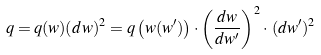<formula> <loc_0><loc_0><loc_500><loc_500>q = q ( w ) ( d w ) ^ { 2 } = q \left ( w ( w ^ { \prime } ) \right ) \cdot \left ( \frac { d w } { d w ^ { \prime } } \right ) ^ { 2 } \cdot \, ( d w ^ { \prime } ) ^ { 2 }</formula> 